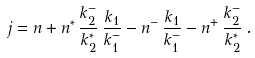Convert formula to latex. <formula><loc_0><loc_0><loc_500><loc_500>j = n + n ^ { * } \, \frac { k _ { 2 } ^ { - } } { k _ { 2 } ^ { * } } \, \frac { k _ { 1 } } { k _ { 1 } ^ { - } } - n ^ { - } \, \frac { k _ { 1 } } { k _ { 1 } ^ { - } } - n ^ { + } \, \frac { k _ { 2 } ^ { - } } { k _ { 2 } ^ { * } } \, .</formula> 